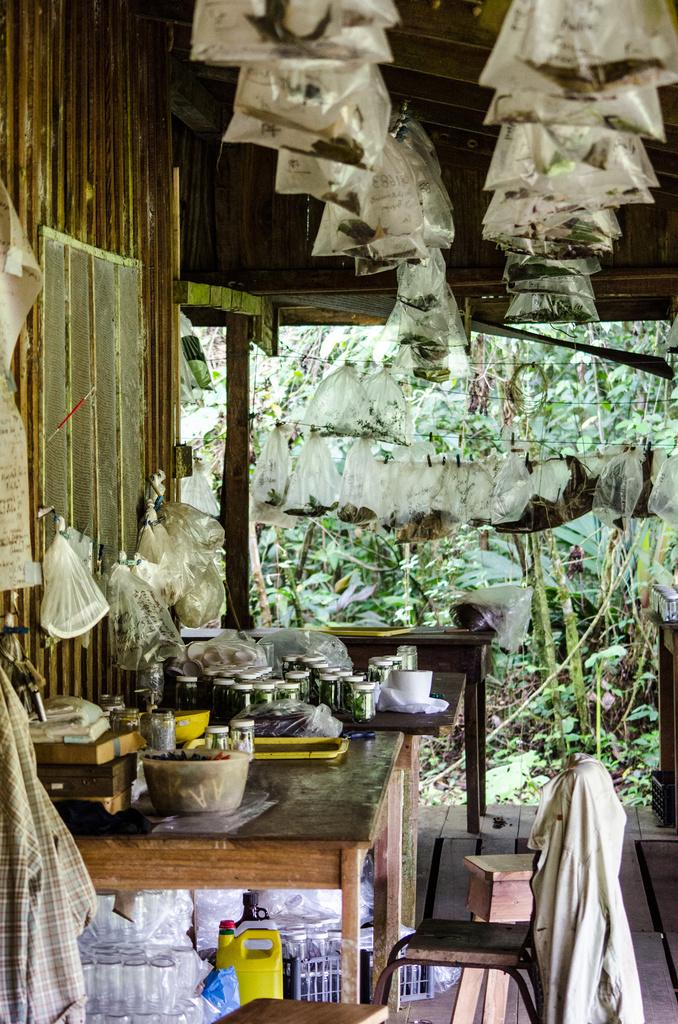What type of covers are used to store items in the image? There are polythene covers with items in the image. Where are the tables located in relation to the wall in the image? The tables are near the wall in the image. What type of furniture is present in the image? There are chairs in the image. What can be seen on the tables in the image? There are many items and bottles on the tables in the image. Can you describe the stick that the stranger is holding in the image? There is no stick or stranger present in the image. 